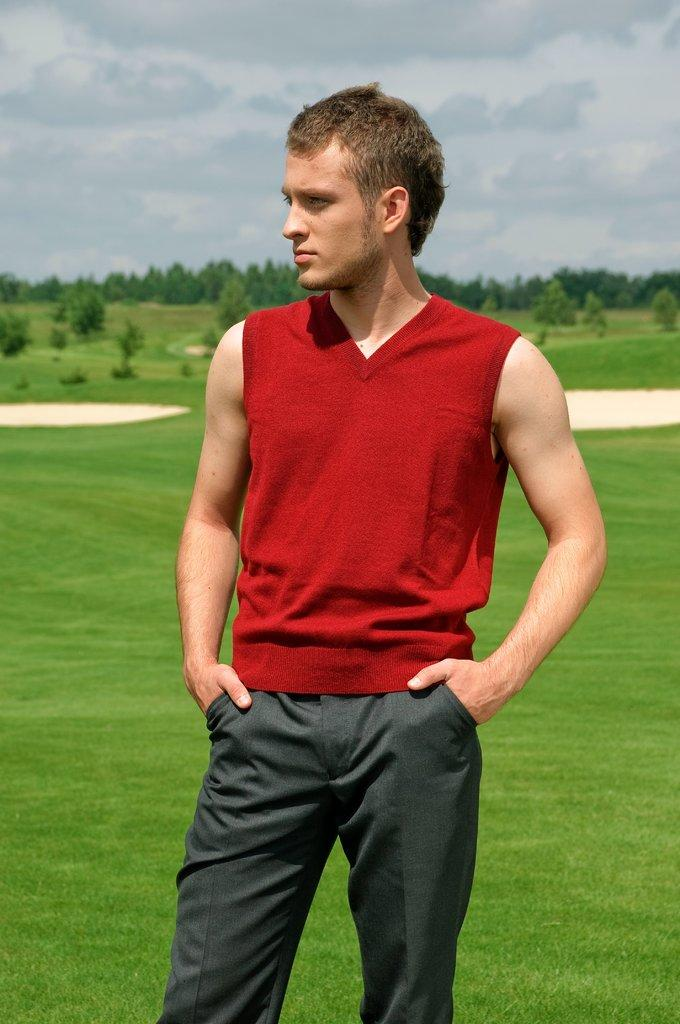What is the main subject of the image? There is a man standing in the image. What can be seen in the background of the image? There are trees in the background of the image. What is visible at the bottom of the image? The ground is visible at the bottom of the image. What type of drink is the man holding in the image? There is no drink visible in the image; the man is not holding anything. 